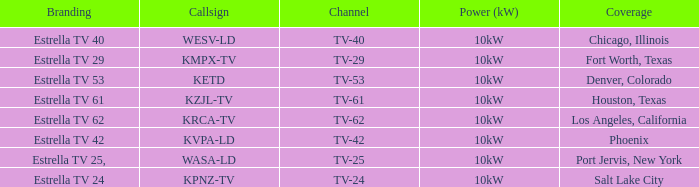What's the power generation for channel tv-29? 10kW. 